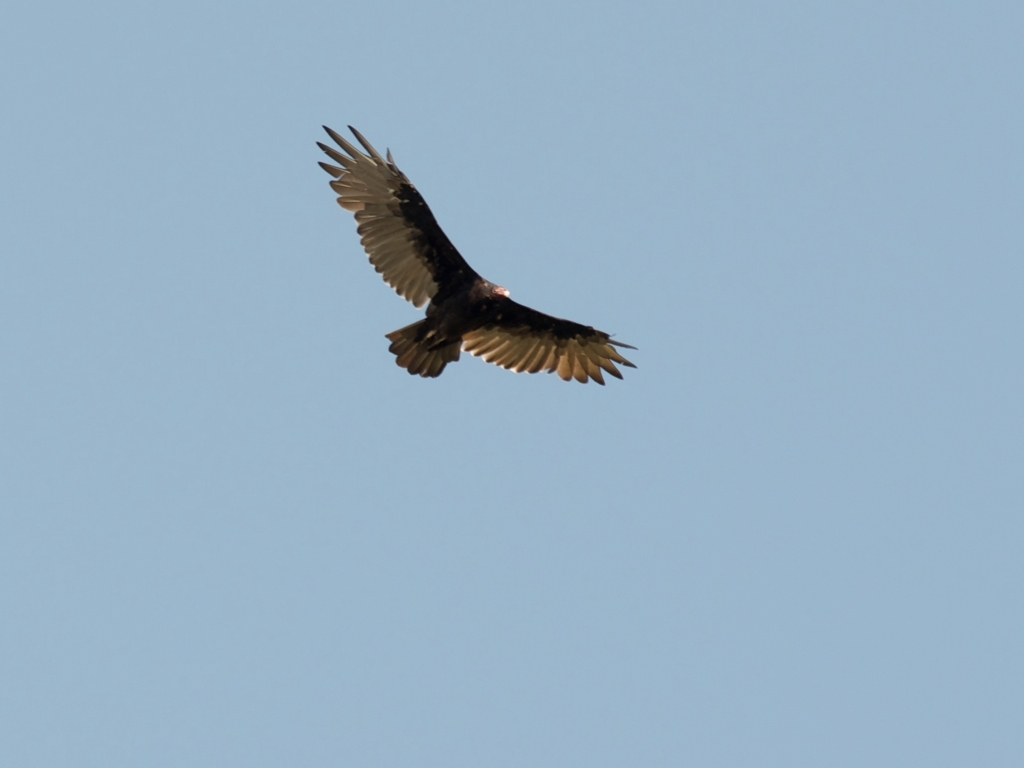What can you say about the details and textures of the main subject? A. Clear B. Fuzzy C. Unclear D. Lacking in texture Answer with the option's letter from the given choices directly. The details and textures of the bird in flight, which appears to be the main subject, are quite clear, showcasing the intricate feather patterns and the contrast against the blue sky. The edges of the bird are well-defined, and the feathers on the wings display a gradient of colors that indicates good lighting and sharp focusing by the camera. The image captures the majesty and grace of the bird's flight with sufficient clarity, thus the answer to the original question is A (Clear). 